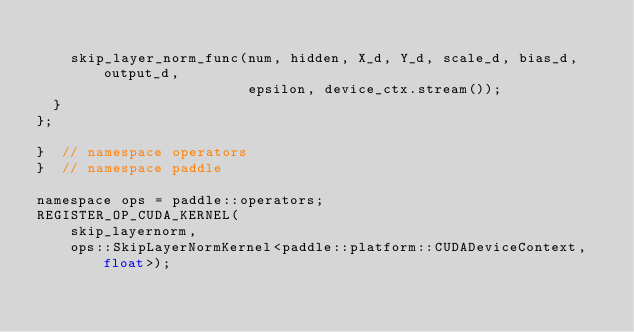Convert code to text. <code><loc_0><loc_0><loc_500><loc_500><_Cuda_>
    skip_layer_norm_func(num, hidden, X_d, Y_d, scale_d, bias_d, output_d,
                         epsilon, device_ctx.stream());
  }
};

}  // namespace operators
}  // namespace paddle

namespace ops = paddle::operators;
REGISTER_OP_CUDA_KERNEL(
    skip_layernorm,
    ops::SkipLayerNormKernel<paddle::platform::CUDADeviceContext, float>);
</code> 